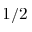<formula> <loc_0><loc_0><loc_500><loc_500>1 / 2</formula> 